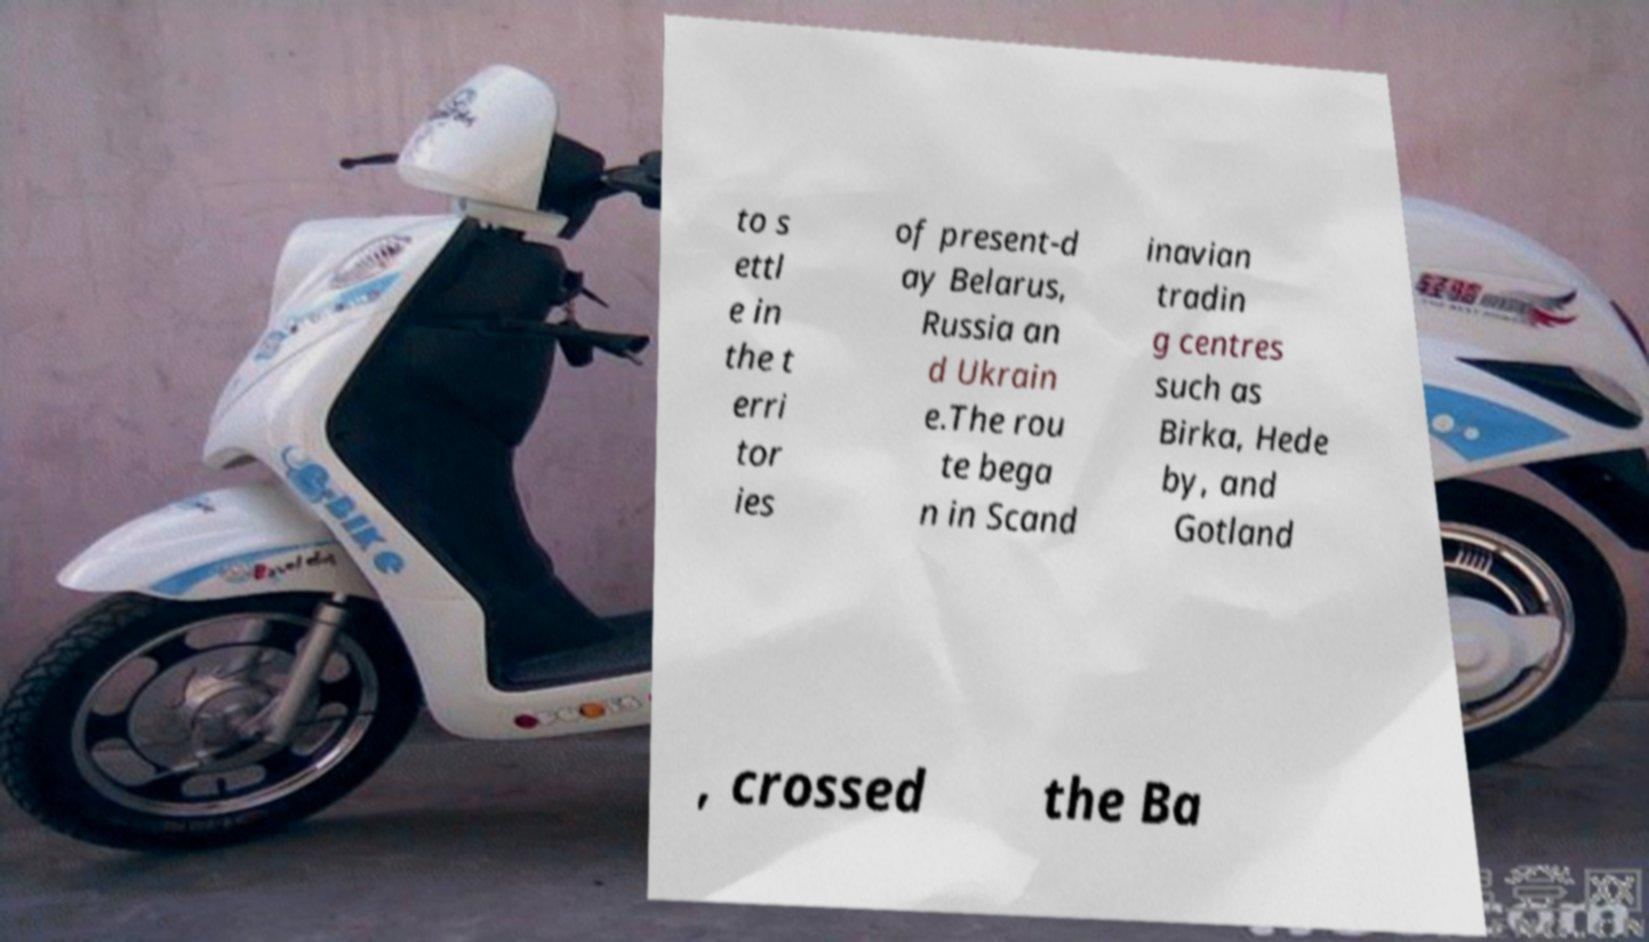Can you read and provide the text displayed in the image?This photo seems to have some interesting text. Can you extract and type it out for me? to s ettl e in the t erri tor ies of present-d ay Belarus, Russia an d Ukrain e.The rou te bega n in Scand inavian tradin g centres such as Birka, Hede by, and Gotland , crossed the Ba 